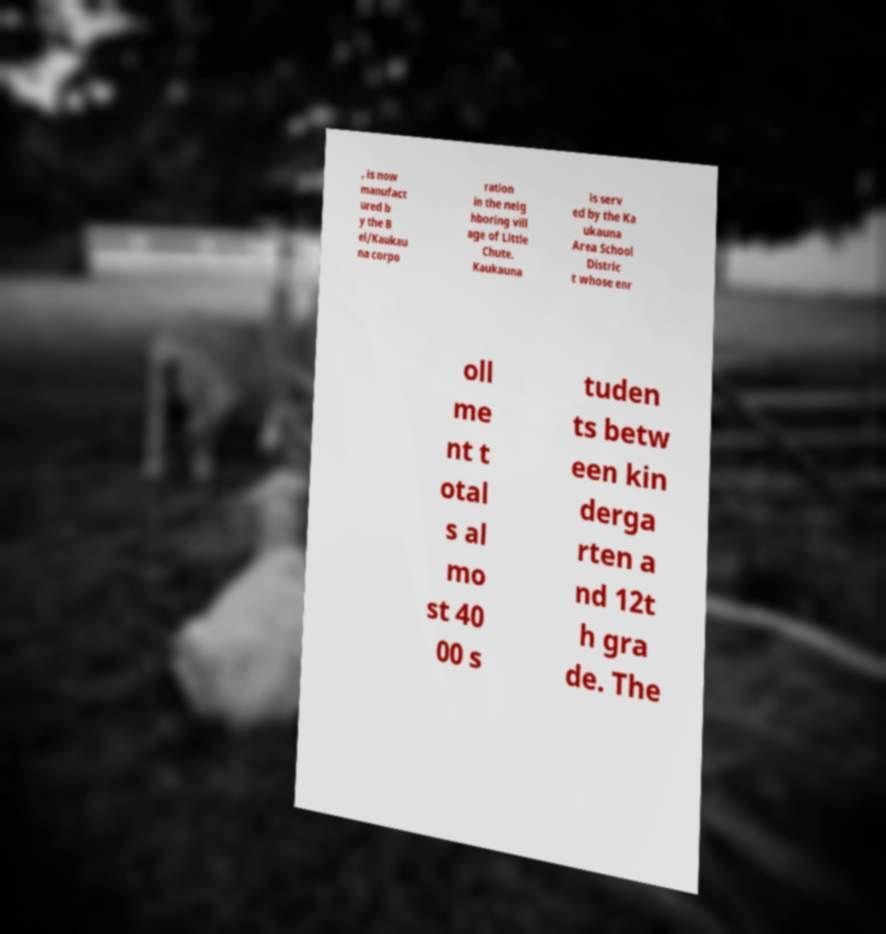Can you accurately transcribe the text from the provided image for me? , is now manufact ured b y the B el/Kaukau na corpo ration in the neig hboring vill age of Little Chute. Kaukauna is serv ed by the Ka ukauna Area School Distric t whose enr oll me nt t otal s al mo st 40 00 s tuden ts betw een kin derga rten a nd 12t h gra de. The 